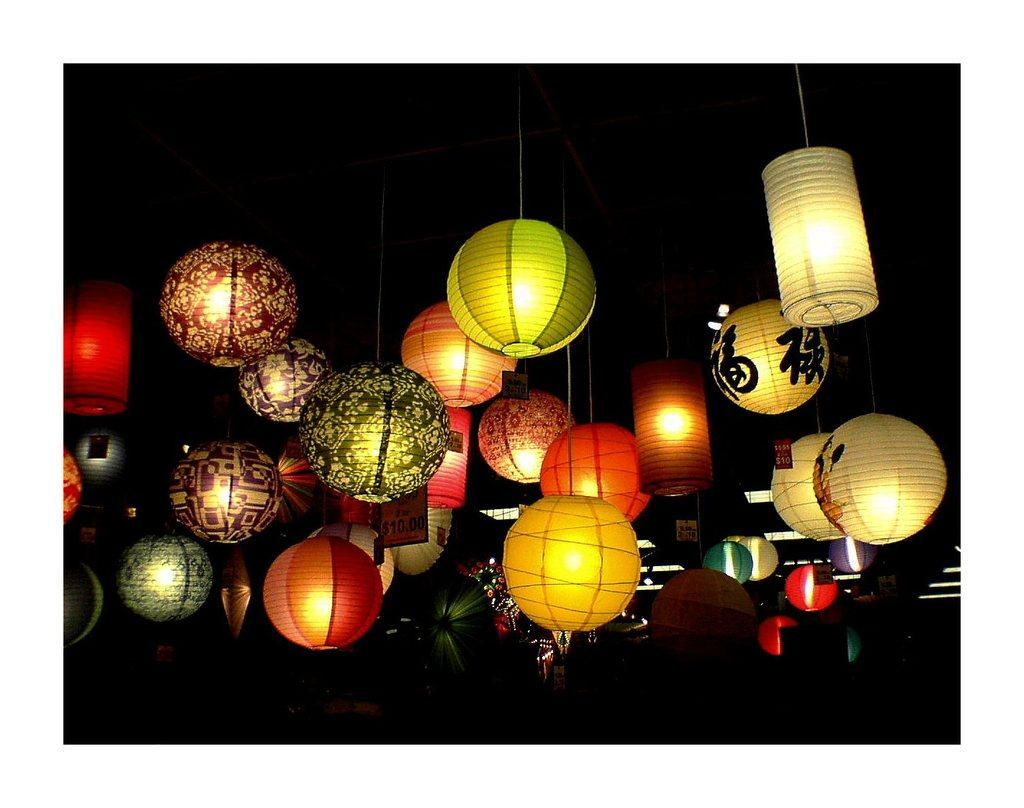What is hanging from the ceiling in the image? There are lights attached to the ceiling in the image. How many lights can be seen on the ceiling? The number of lights on the ceiling is not specified in the provided facts, so it cannot be determined. What might the purpose of these lights be? The purpose of these lights could be for illumination or decoration. What type of badge is being used to season the food in the image? There is no badge or food present in the image; it only features lights attached to the ceiling. 